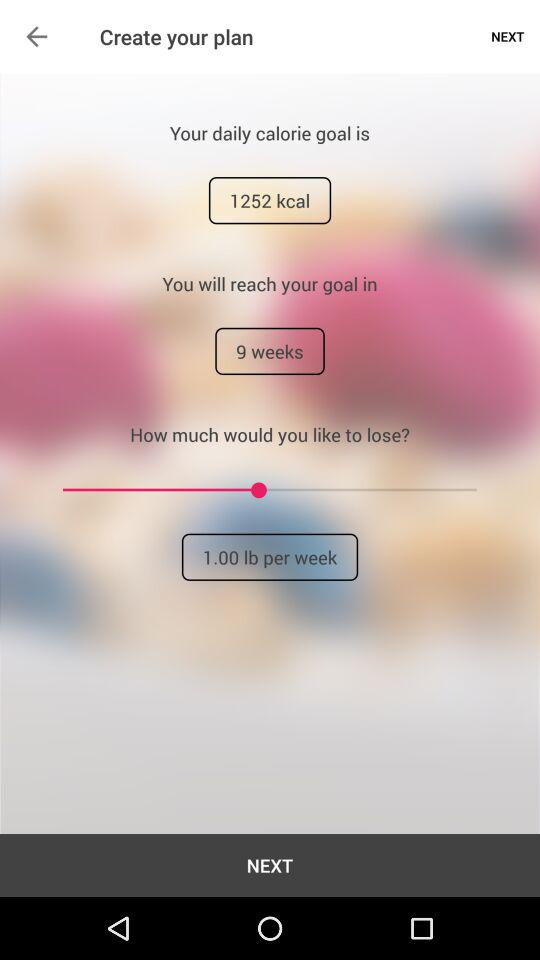What is my daily calorie goal? Your daily calorie goal is 1252 kcal. 